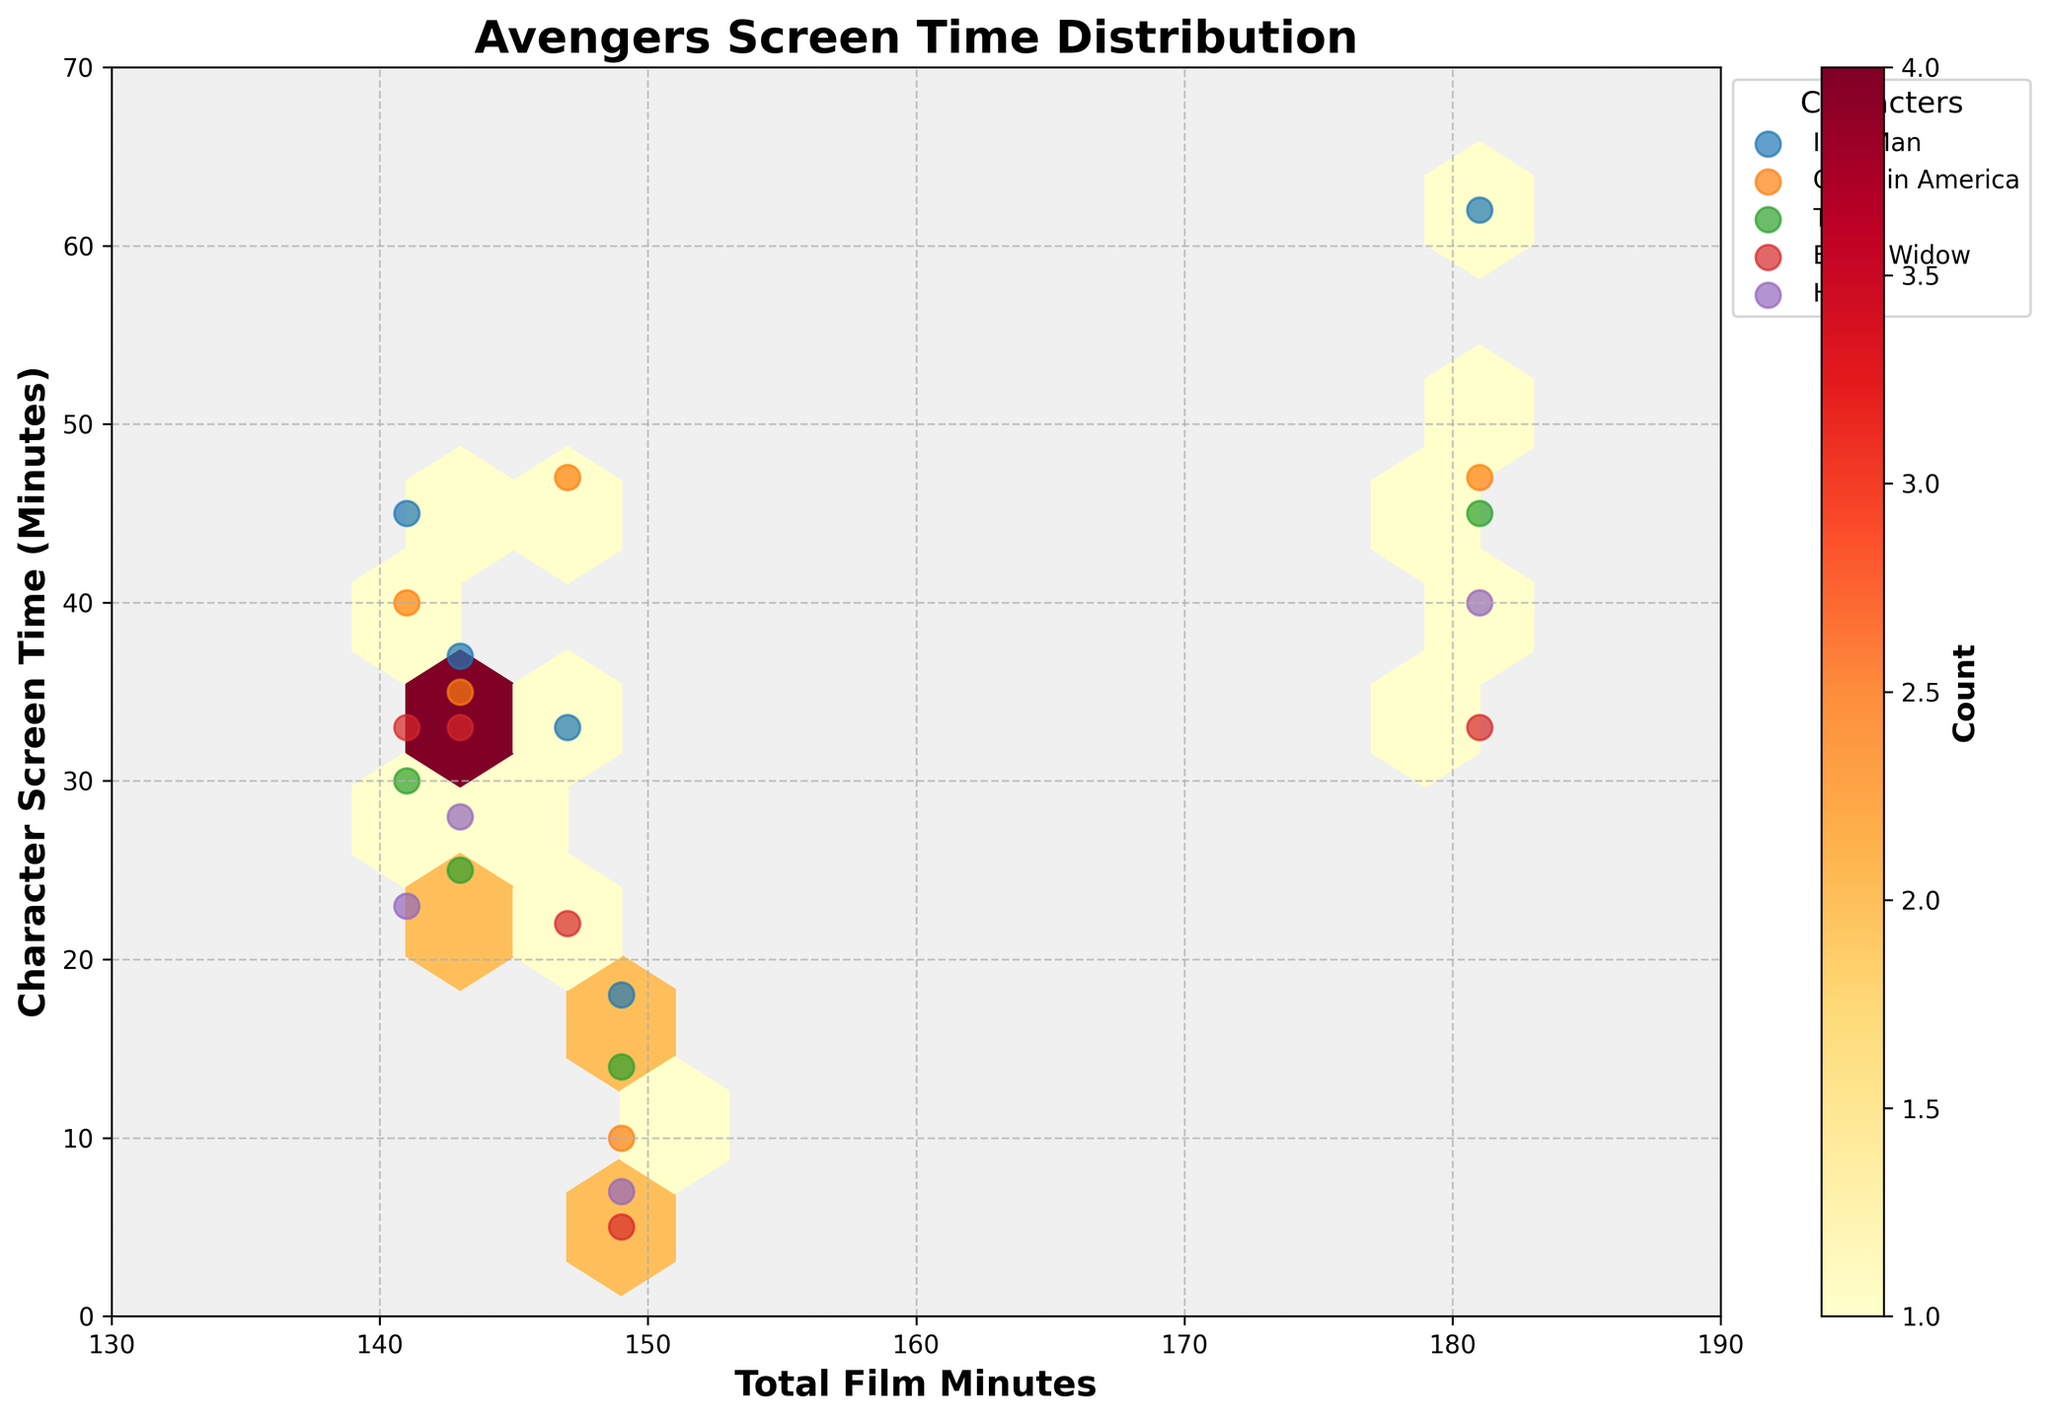What's the title of this hexbin plot? The title is located at the top of the plot and generally gives an insight into what the figure is about.
Answer: Avengers Screen Time Distribution What are the ranges of the x-axis and y-axis? The ranges of the axes can be observed by looking at the start and end values of the scales on each axis. The x-axis ranges from 130 to 190, and the y-axis ranges from 0 to 70.
Answer: x-axis: 130 to 190, y-axis: 0 to 70 Which character has the highest screen time in *Avengers: Endgame*? Look for the data point with the highest y-value corresponding to *Avengers: Endgame* in the scatter plot. Iron Man has 62 minutes of screen time.
Answer: Iron Man Which film has the highest total minutes? Spot the maximum x-axis value among the scattered data points. The highest value of 181 corresponds to *Avengers: Endgame*.
Answer: Avengers: Endgame How many unique characters are presented in the legend? Count the number of different labels listed in the plot legend. There are 5 characters: Iron Man, Captain America, Thor, Black Widow, and Hulk.
Answer: 5 In which films does Iron Man have more screen time than Captain America? Compare the screen times of Iron Man and Captain America in each film by checking data points marked with their respective legend entries. Iron Man has more screen time in *Avengers: Infinity War* and *Avengers: Age of Ultron*.
Answer: Avengers: Infinity War, Avengers: Age of Ultron What's the difference in screen time between Iron Man and Thor in *Avengers: Endgame*? Find the y-values of both characters in *Avengers: Endgame* and subtract the smaller value from the larger one. Iron Man has 62 minutes and Thor has 45 minutes, so the difference is 62 - 45 = 17 minutes.
Answer: 17 minutes Which film has the least screen time for Black Widow, and how many minutes is it? Look for the data point for Black Widow with the smallest y-value. Black Widow has the least screen time, 5 minutes, in *Avengers: Infinity War*.
Answer: Avengers: Infinity War, 5 minutes What does the color indicate in this hexbin plot? The color indicates the count of data points falling within each hexagon. Darker colors represent higher counts.
Answer: Count 